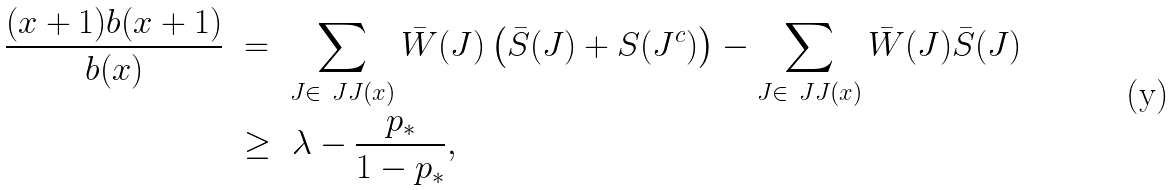<formula> <loc_0><loc_0><loc_500><loc_500>\frac { ( x + 1 ) b ( x + 1 ) } { b ( x ) } \ & = \ \sum _ { J \in \ J J ( x ) } \bar { W } ( J ) \left ( \bar { S } ( J ) + S ( J ^ { c } ) \right ) - \sum _ { J \in \ J J ( x ) } \bar { W } ( J ) \bar { S } ( J ) \\ & \geq \ \lambda - \frac { p _ { * } } { 1 - p _ { * } } ,</formula> 